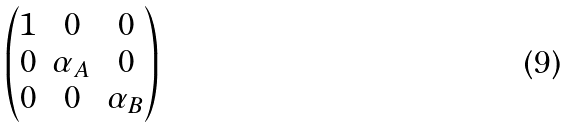<formula> <loc_0><loc_0><loc_500><loc_500>\begin{pmatrix} 1 & 0 & 0 \\ 0 & \alpha _ { A } & 0 \\ 0 & 0 & \alpha _ { B } \end{pmatrix}</formula> 